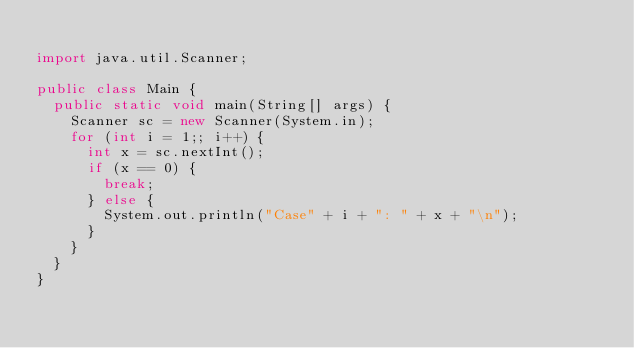<code> <loc_0><loc_0><loc_500><loc_500><_Java_>
import java.util.Scanner;

public class Main {
	public static void main(String[] args) {
		Scanner sc = new Scanner(System.in);
		for (int i = 1;; i++) {
			int x = sc.nextInt();
			if (x == 0) {
				break;
			} else {
				System.out.println("Case" + i + ": " + x + "\n");
			}
		}
	}
}</code> 